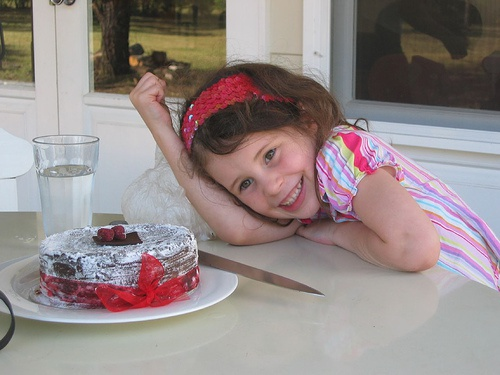Describe the objects in this image and their specific colors. I can see people in darkgreen, gray, darkgray, maroon, and lightpink tones, dining table in darkgreen, darkgray, and gray tones, cake in darkgreen, darkgray, gray, brown, and maroon tones, cup in darkgreen, darkgray, and lightgray tones, and knife in darkgreen, gray, darkgray, and black tones in this image. 